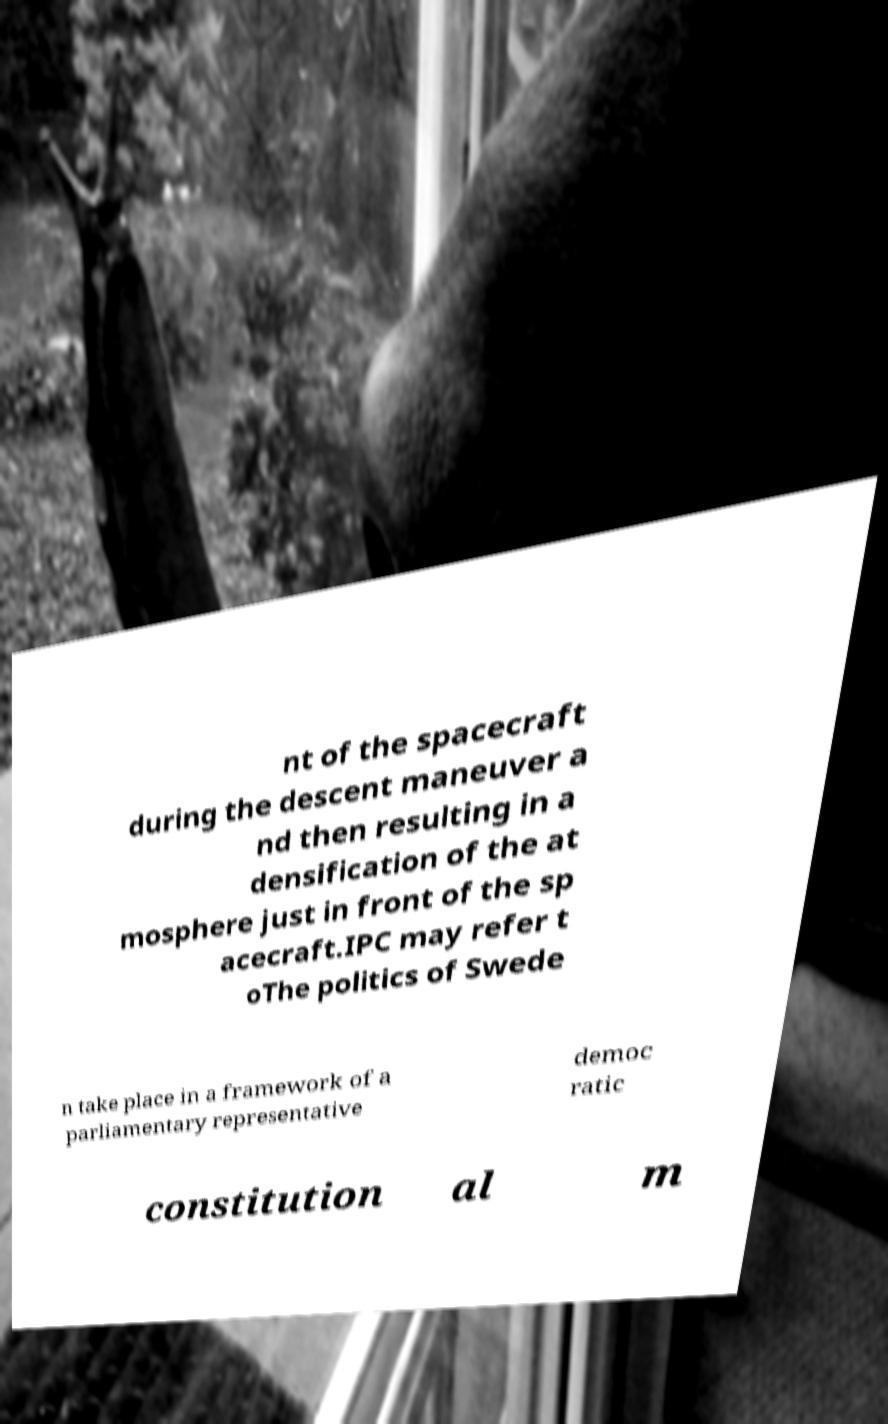Can you read and provide the text displayed in the image?This photo seems to have some interesting text. Can you extract and type it out for me? nt of the spacecraft during the descent maneuver a nd then resulting in a densification of the at mosphere just in front of the sp acecraft.IPC may refer t oThe politics of Swede n take place in a framework of a parliamentary representative democ ratic constitution al m 